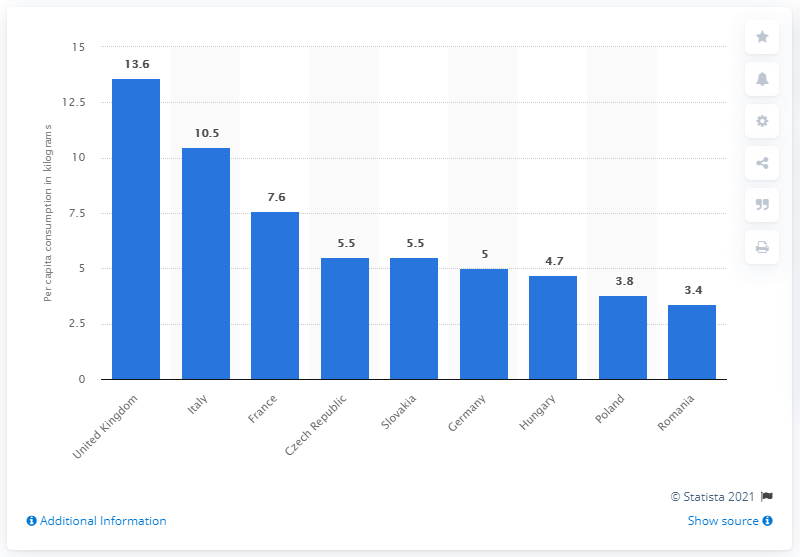Specify some key components in this picture. France is in third place in terms of biscuit consumption. 